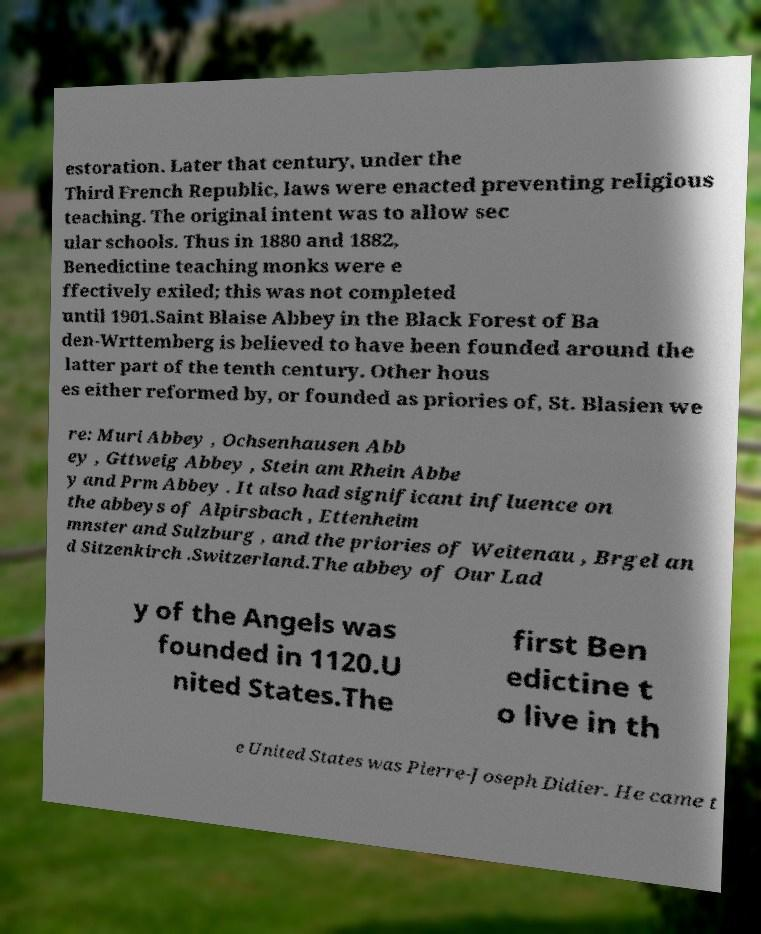Please identify and transcribe the text found in this image. estoration. Later that century, under the Third French Republic, laws were enacted preventing religious teaching. The original intent was to allow sec ular schools. Thus in 1880 and 1882, Benedictine teaching monks were e ffectively exiled; this was not completed until 1901.Saint Blaise Abbey in the Black Forest of Ba den-Wrttemberg is believed to have been founded around the latter part of the tenth century. Other hous es either reformed by, or founded as priories of, St. Blasien we re: Muri Abbey , Ochsenhausen Abb ey , Gttweig Abbey , Stein am Rhein Abbe y and Prm Abbey . It also had significant influence on the abbeys of Alpirsbach , Ettenheim mnster and Sulzburg , and the priories of Weitenau , Brgel an d Sitzenkirch .Switzerland.The abbey of Our Lad y of the Angels was founded in 1120.U nited States.The first Ben edictine t o live in th e United States was Pierre-Joseph Didier. He came t 